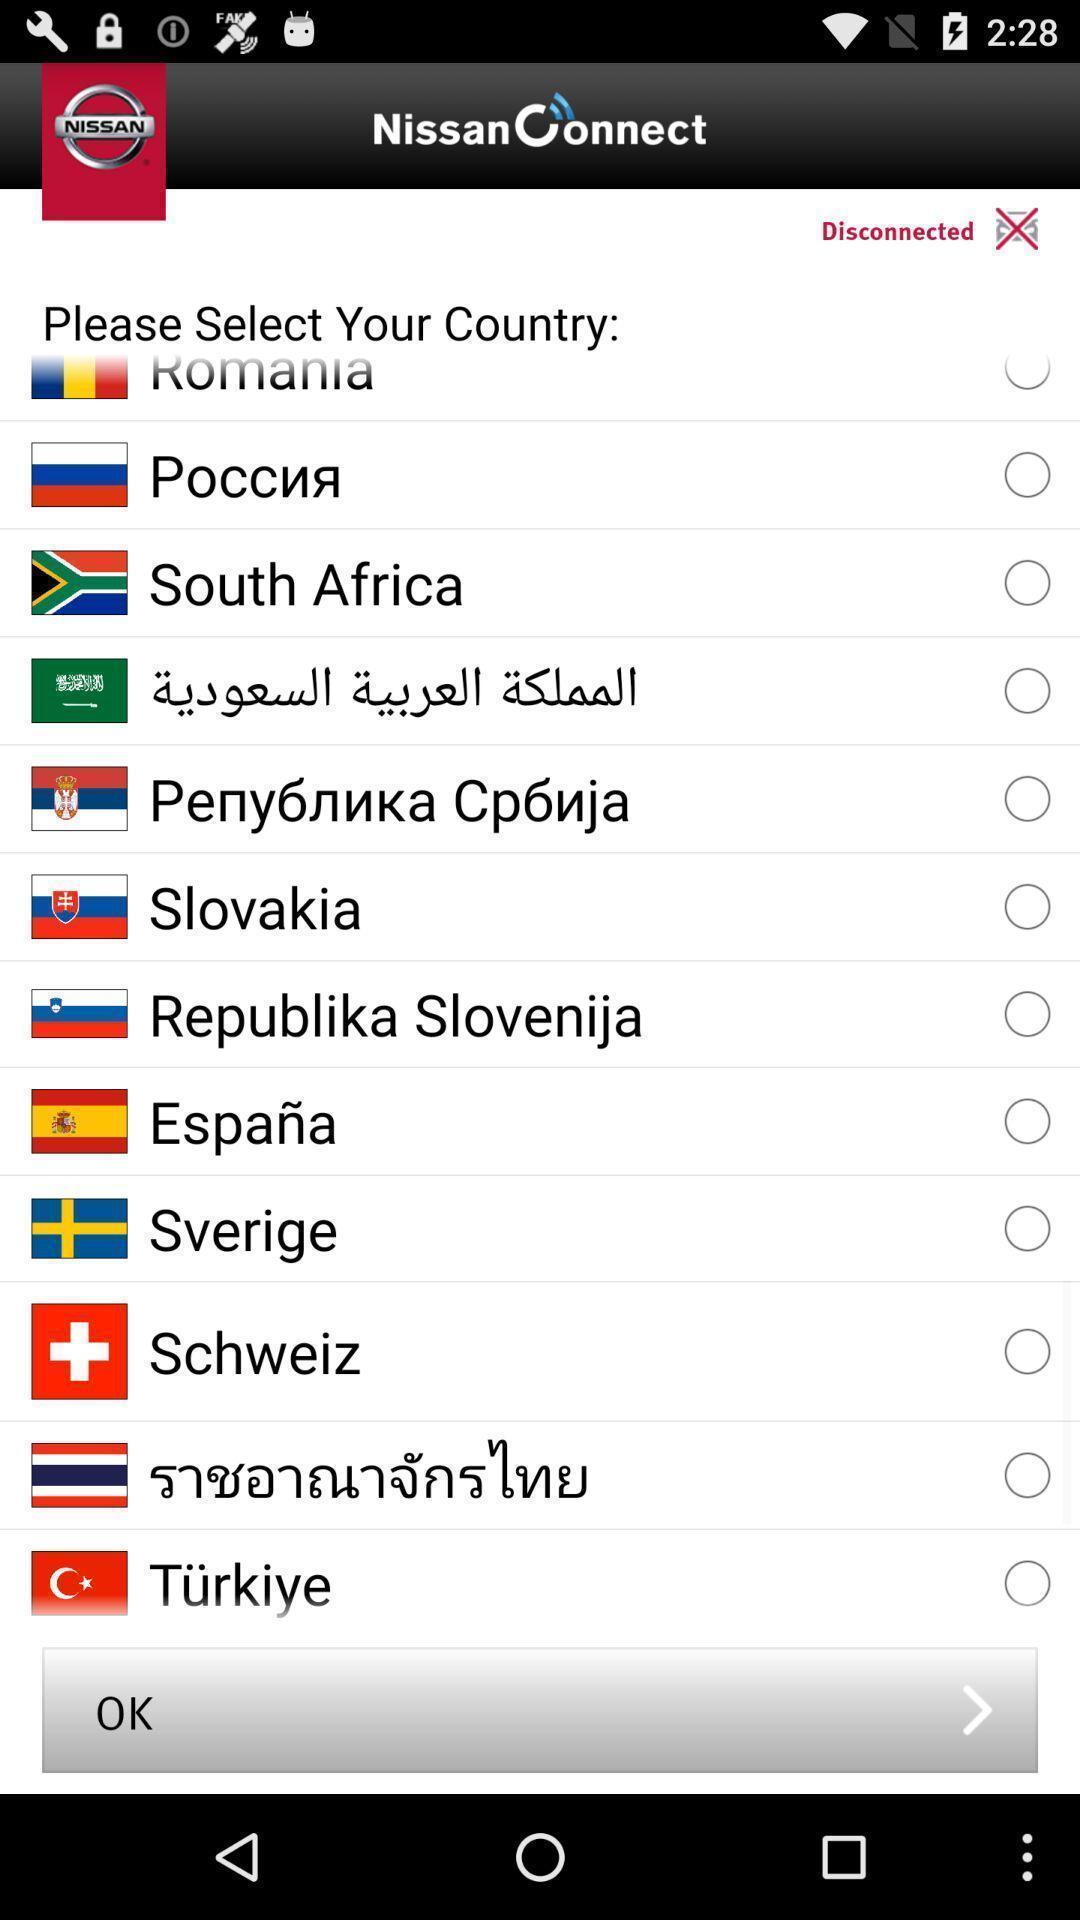Explain what's happening in this screen capture. Screen showing list of countries to select. 